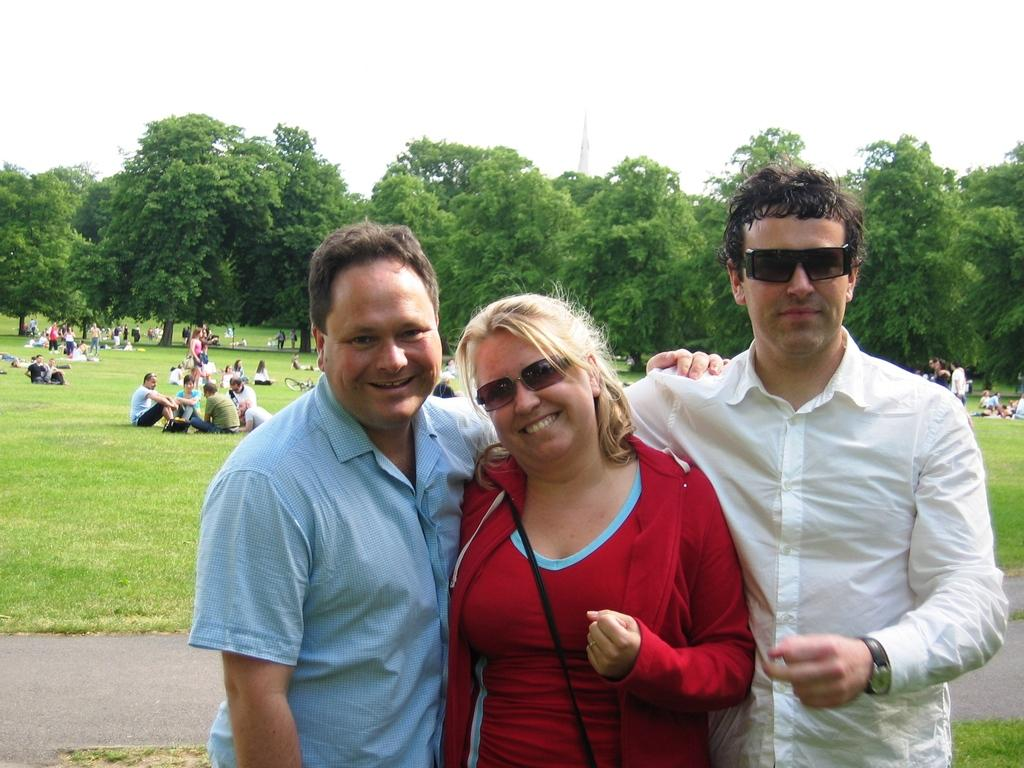What are the people in the foreground of the image doing? The people in the foreground of the image are standing on the ground and smiling. Can you describe the people in the background? In the background, there are people sitting and standing on the ground. What can be seen in the background of the image? There are trees, a tower, and the sky visible in the background. What type of lumber is being used to build the tower in the image? There is no tower being built in the image, and no lumber is visible. What does the image smell like? The image is a visual representation and does not have a smell. 